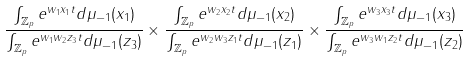Convert formula to latex. <formula><loc_0><loc_0><loc_500><loc_500>\frac { \int _ { \mathbb { Z } _ { p } } e ^ { w _ { 1 } x _ { 1 } t } d \mu _ { - 1 } ( x _ { 1 } ) } { \int _ { \mathbb { Z } _ { p } } e ^ { w _ { 1 } w _ { 2 } z _ { 3 } t } d \mu _ { - 1 } ( z _ { 3 } ) } \times \frac { \int _ { \mathbb { Z } _ { p } } e ^ { w _ { 2 } x _ { 2 } t } d \mu _ { - 1 } ( x _ { 2 } ) } { \int _ { \mathbb { Z } _ { p } } e ^ { w _ { 2 } w _ { 3 } z _ { 1 } t } d \mu _ { - 1 } ( z _ { 1 } ) } \times \frac { \int _ { \mathbb { Z } _ { p } } e ^ { w _ { 3 } x _ { 3 } t } d \mu _ { - 1 } ( x _ { 3 } ) } { \int _ { \mathbb { Z } _ { p } } e ^ { w _ { 3 } w _ { 1 } z _ { 2 } t } d \mu _ { - 1 } ( z _ { 2 } ) }</formula> 